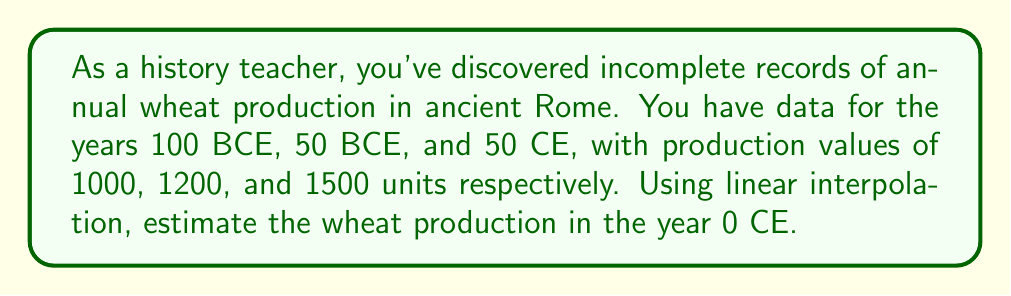Help me with this question. Let's approach this step-by-step using linear interpolation:

1) We'll use the data points from 50 BCE and 50 CE to interpolate the value at 0 CE.

2) Let's define our variables:
   $x_1 = -50$ (50 BCE)
   $y_1 = 1200$ (production at 50 BCE)
   $x_2 = 50$ (50 CE)
   $y_2 = 1500$ (production at 50 CE)
   $x = 0$ (the year we're interpolating for)

3) The linear interpolation formula is:

   $$y = y_1 + \frac{(x - x_1)(y_2 - y_1)}{(x_2 - x_1)}$$

4) Plugging in our values:

   $$y = 1200 + \frac{(0 - (-50))(1500 - 1200)}{(50 - (-50))}$$

5) Simplify:

   $$y = 1200 + \frac{50 \cdot 300}{100} = 1200 + \frac{15000}{100}$$

6) Calculate:

   $$y = 1200 + 150 = 1350$$

Therefore, the estimated wheat production in 0 CE is 1350 units.
Answer: 1350 units 